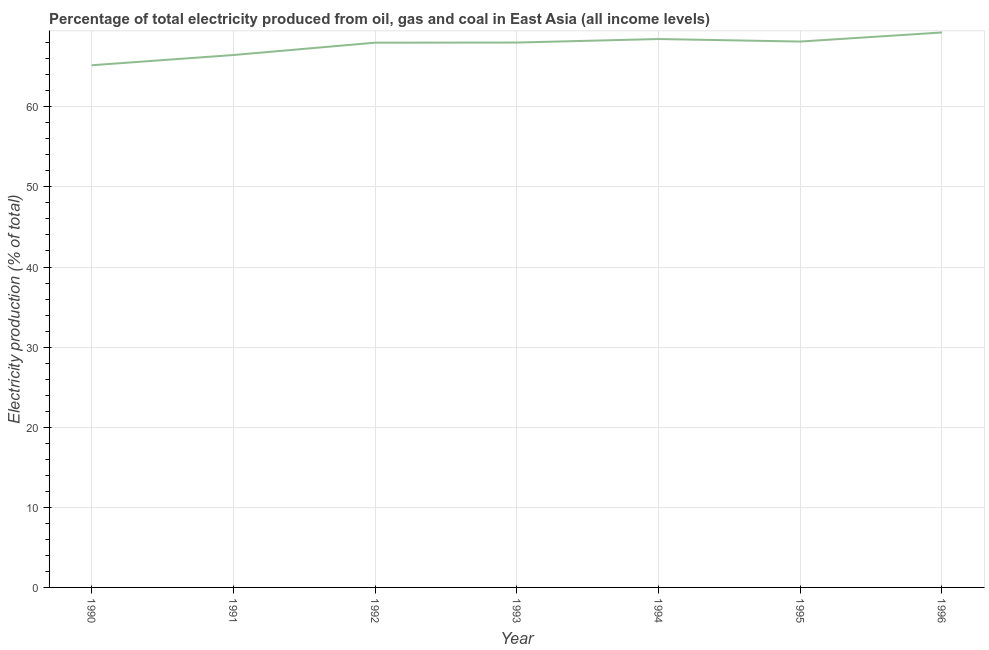What is the electricity production in 1994?
Provide a short and direct response. 68.46. Across all years, what is the maximum electricity production?
Make the answer very short. 69.28. Across all years, what is the minimum electricity production?
Give a very brief answer. 65.19. What is the sum of the electricity production?
Keep it short and to the point. 473.58. What is the difference between the electricity production in 1991 and 1995?
Your response must be concise. -1.68. What is the average electricity production per year?
Provide a succinct answer. 67.65. What is the median electricity production?
Provide a succinct answer. 68.02. Do a majority of the years between 1993 and 1992 (inclusive) have electricity production greater than 14 %?
Make the answer very short. No. What is the ratio of the electricity production in 1992 to that in 1993?
Give a very brief answer. 1. What is the difference between the highest and the second highest electricity production?
Make the answer very short. 0.82. What is the difference between the highest and the lowest electricity production?
Provide a short and direct response. 4.09. How many lines are there?
Your answer should be compact. 1. How many years are there in the graph?
Offer a terse response. 7. Does the graph contain any zero values?
Provide a succinct answer. No. Does the graph contain grids?
Make the answer very short. Yes. What is the title of the graph?
Your answer should be compact. Percentage of total electricity produced from oil, gas and coal in East Asia (all income levels). What is the label or title of the Y-axis?
Give a very brief answer. Electricity production (% of total). What is the Electricity production (% of total) in 1990?
Give a very brief answer. 65.19. What is the Electricity production (% of total) in 1991?
Make the answer very short. 66.47. What is the Electricity production (% of total) in 1992?
Your answer should be very brief. 68.01. What is the Electricity production (% of total) in 1993?
Ensure brevity in your answer.  68.02. What is the Electricity production (% of total) in 1994?
Provide a short and direct response. 68.46. What is the Electricity production (% of total) of 1995?
Provide a short and direct response. 68.15. What is the Electricity production (% of total) of 1996?
Provide a short and direct response. 69.28. What is the difference between the Electricity production (% of total) in 1990 and 1991?
Provide a short and direct response. -1.28. What is the difference between the Electricity production (% of total) in 1990 and 1992?
Keep it short and to the point. -2.82. What is the difference between the Electricity production (% of total) in 1990 and 1993?
Offer a terse response. -2.83. What is the difference between the Electricity production (% of total) in 1990 and 1994?
Keep it short and to the point. -3.27. What is the difference between the Electricity production (% of total) in 1990 and 1995?
Ensure brevity in your answer.  -2.96. What is the difference between the Electricity production (% of total) in 1990 and 1996?
Keep it short and to the point. -4.09. What is the difference between the Electricity production (% of total) in 1991 and 1992?
Your response must be concise. -1.54. What is the difference between the Electricity production (% of total) in 1991 and 1993?
Your answer should be very brief. -1.56. What is the difference between the Electricity production (% of total) in 1991 and 1994?
Make the answer very short. -2. What is the difference between the Electricity production (% of total) in 1991 and 1995?
Ensure brevity in your answer.  -1.68. What is the difference between the Electricity production (% of total) in 1991 and 1996?
Your response must be concise. -2.82. What is the difference between the Electricity production (% of total) in 1992 and 1993?
Provide a succinct answer. -0.01. What is the difference between the Electricity production (% of total) in 1992 and 1994?
Make the answer very short. -0.45. What is the difference between the Electricity production (% of total) in 1992 and 1995?
Your response must be concise. -0.14. What is the difference between the Electricity production (% of total) in 1992 and 1996?
Offer a very short reply. -1.27. What is the difference between the Electricity production (% of total) in 1993 and 1994?
Your answer should be very brief. -0.44. What is the difference between the Electricity production (% of total) in 1993 and 1995?
Keep it short and to the point. -0.13. What is the difference between the Electricity production (% of total) in 1993 and 1996?
Keep it short and to the point. -1.26. What is the difference between the Electricity production (% of total) in 1994 and 1995?
Provide a succinct answer. 0.31. What is the difference between the Electricity production (% of total) in 1994 and 1996?
Your answer should be compact. -0.82. What is the difference between the Electricity production (% of total) in 1995 and 1996?
Offer a very short reply. -1.13. What is the ratio of the Electricity production (% of total) in 1990 to that in 1991?
Keep it short and to the point. 0.98. What is the ratio of the Electricity production (% of total) in 1990 to that in 1993?
Offer a very short reply. 0.96. What is the ratio of the Electricity production (% of total) in 1990 to that in 1995?
Your answer should be very brief. 0.96. What is the ratio of the Electricity production (% of total) in 1990 to that in 1996?
Make the answer very short. 0.94. What is the ratio of the Electricity production (% of total) in 1991 to that in 1996?
Your answer should be very brief. 0.96. What is the ratio of the Electricity production (% of total) in 1992 to that in 1993?
Offer a very short reply. 1. What is the ratio of the Electricity production (% of total) in 1992 to that in 1995?
Your answer should be very brief. 1. What is the ratio of the Electricity production (% of total) in 1992 to that in 1996?
Offer a very short reply. 0.98. What is the ratio of the Electricity production (% of total) in 1993 to that in 1994?
Give a very brief answer. 0.99. What is the ratio of the Electricity production (% of total) in 1993 to that in 1996?
Offer a terse response. 0.98. What is the ratio of the Electricity production (% of total) in 1994 to that in 1995?
Keep it short and to the point. 1. What is the ratio of the Electricity production (% of total) in 1994 to that in 1996?
Your answer should be very brief. 0.99. What is the ratio of the Electricity production (% of total) in 1995 to that in 1996?
Keep it short and to the point. 0.98. 